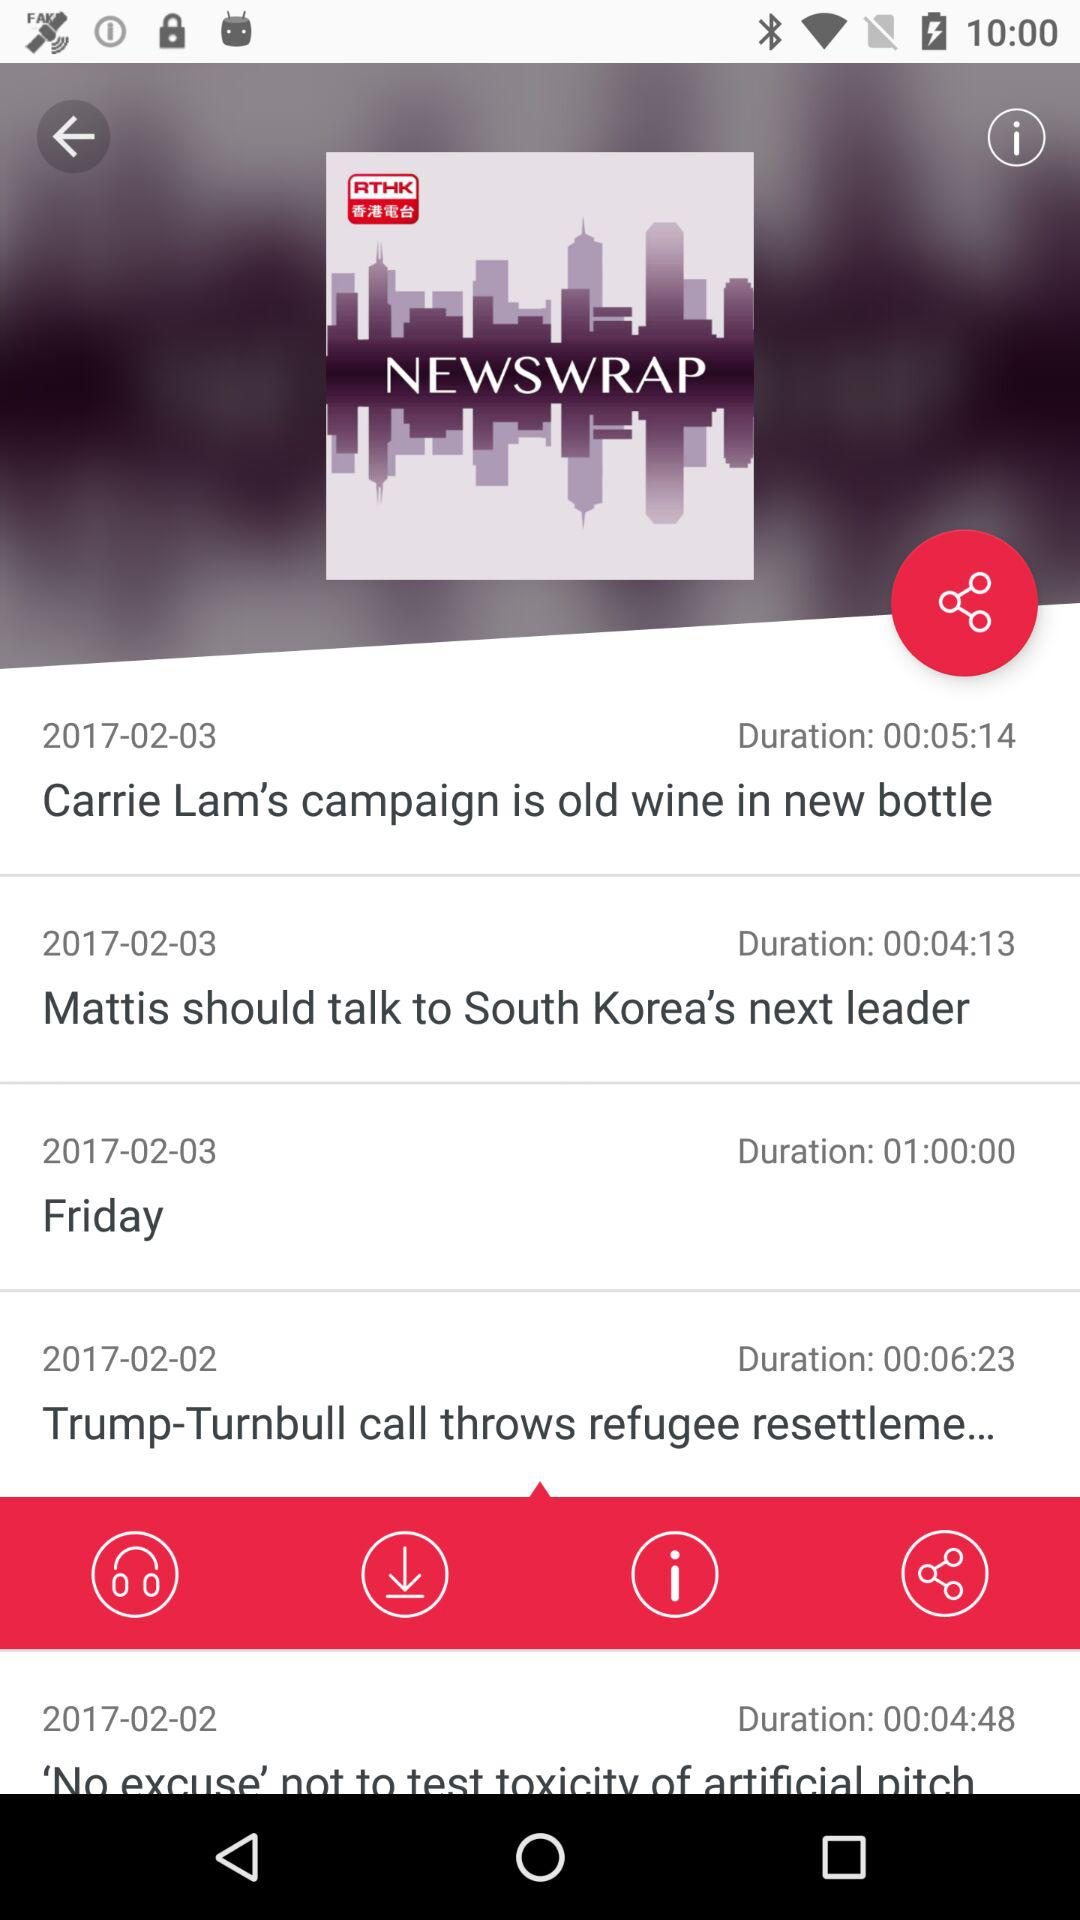How many articles have been downloaded?
When the provided information is insufficient, respond with <no answer>. <no answer> 